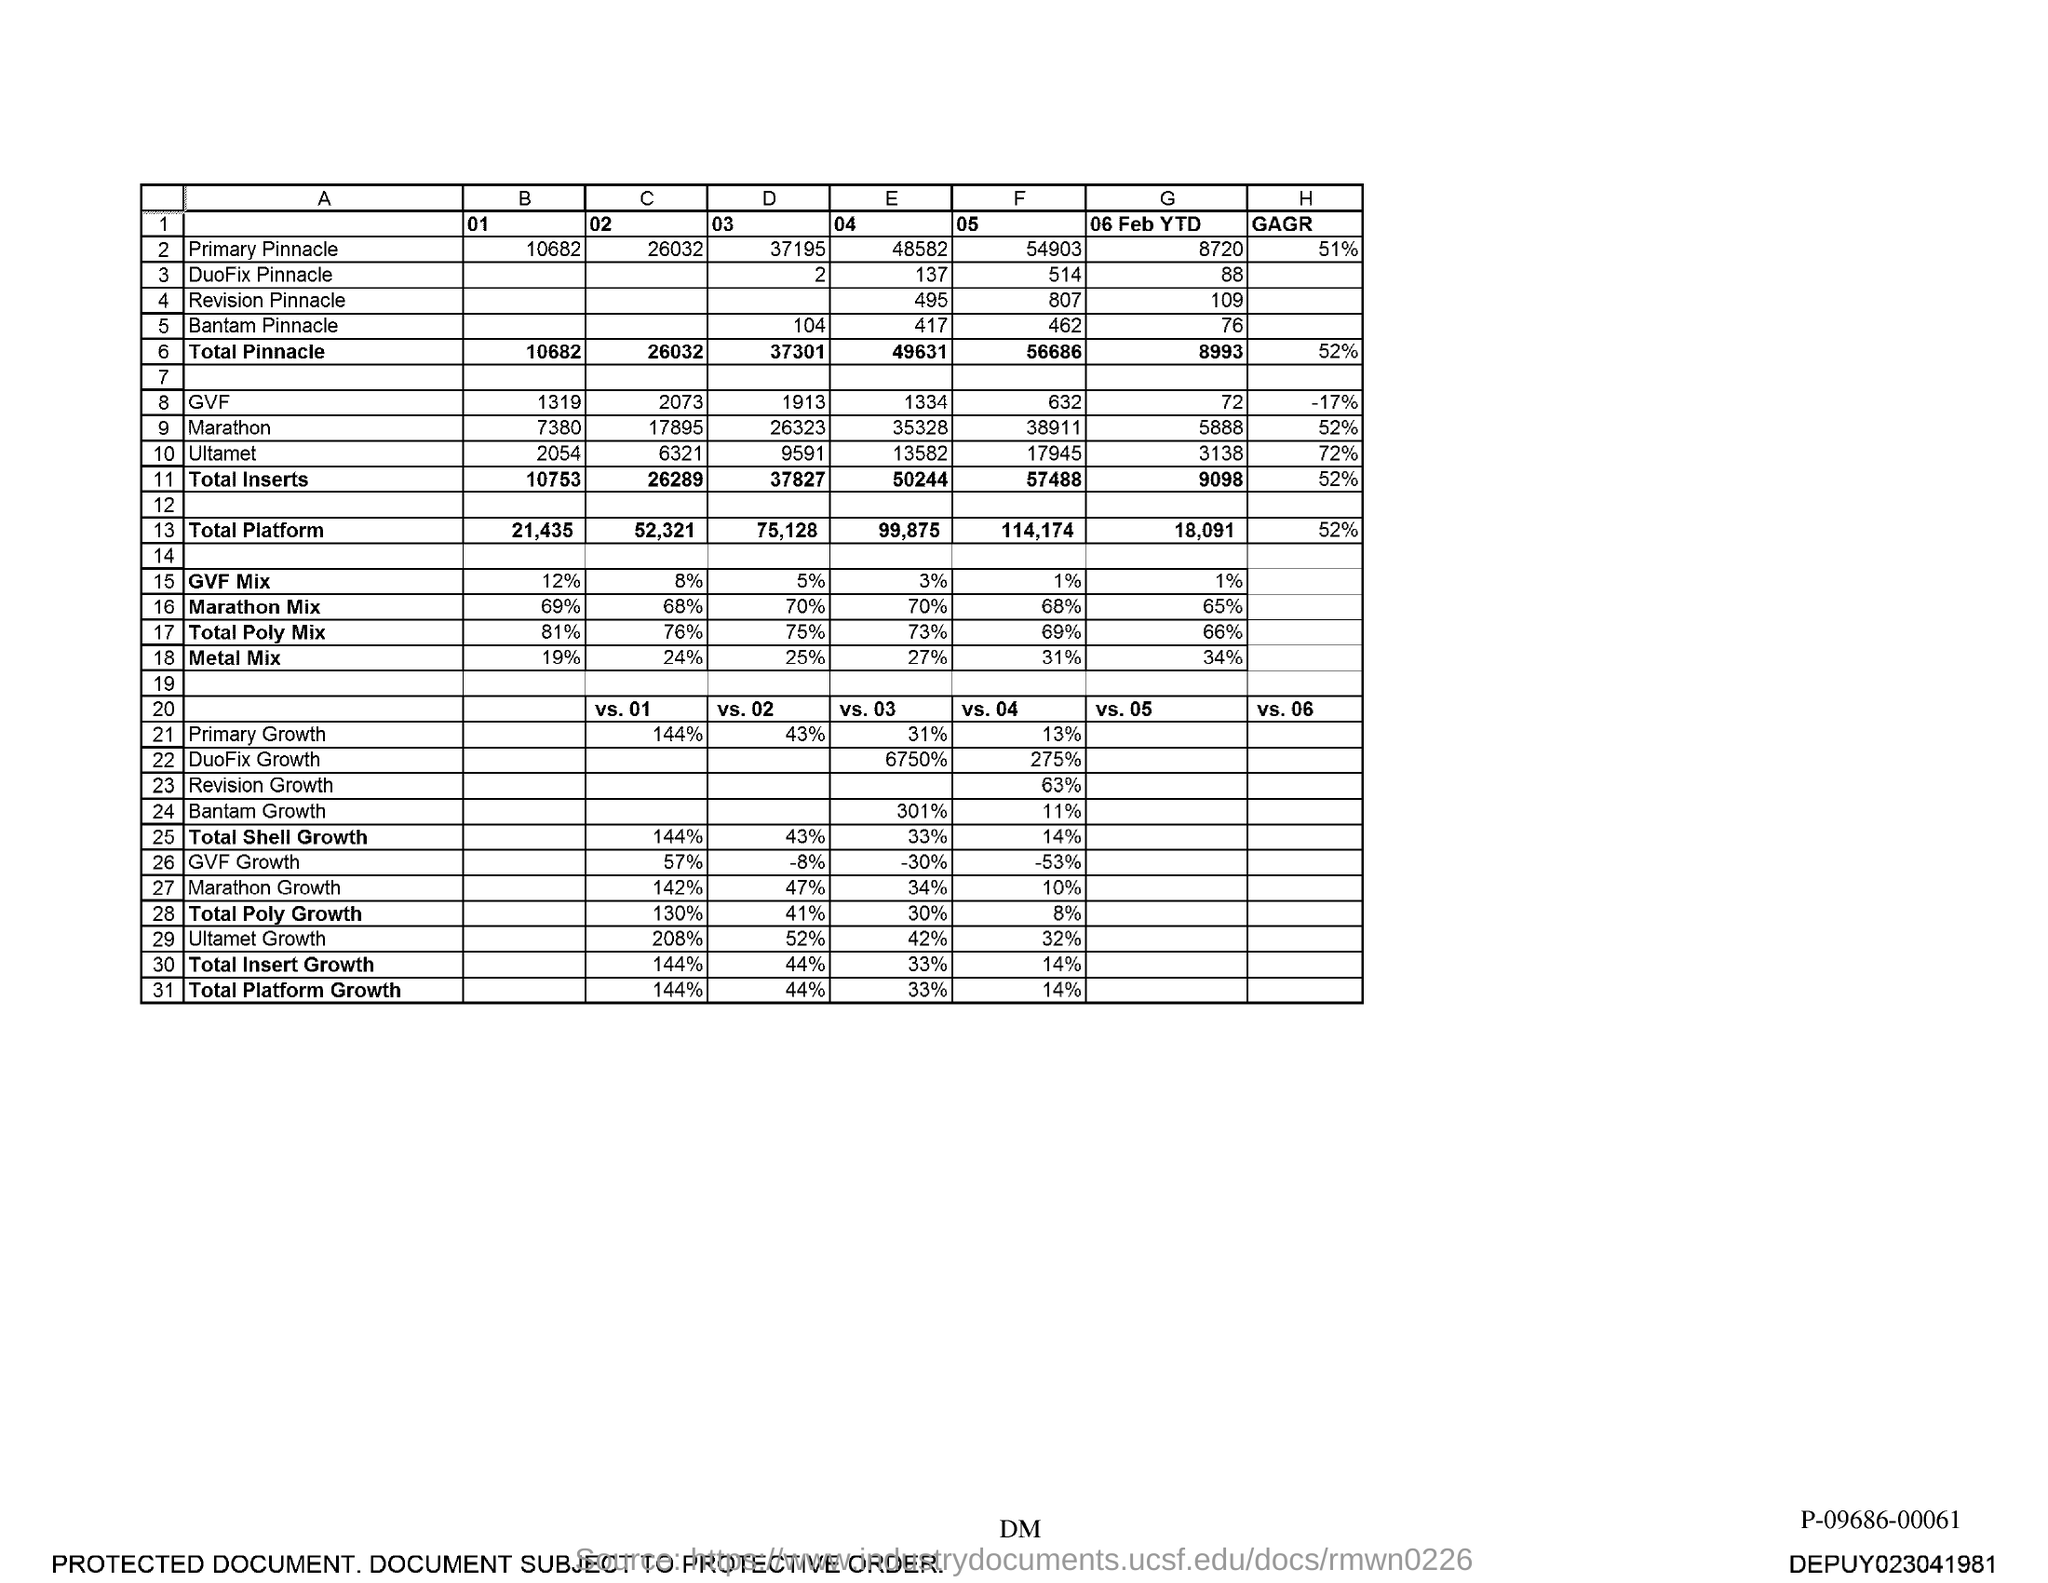What is the "B" "01" Value for Primary Pinnacle?
Your response must be concise. 10682. What is the "B" "01" Value for Total Pinnacle?
Your response must be concise. 10682. What is the "E" "04" Value for Primary Pinnacle?
Keep it short and to the point. 48582. What is the "E" "04" Value for Duofix Pinnacle?
Give a very brief answer. 137. What is the "E" "04" Value for Revision Pinnacle?
Provide a short and direct response. 495. What is the "E" "04" Value for Bantam Pinnacle?
Your answer should be compact. 417. What is the "E" "04" Value for Total Pinnacle?
Offer a terse response. 49631. What is the "F" "05" Value for Primary Pinnacle?
Offer a very short reply. 54903. What is the "F" "05" Value for Duofix Pinnacle?
Offer a terse response. 514. What is the "F" "05" Value for Revision Pinnacle?
Give a very brief answer. 807. 